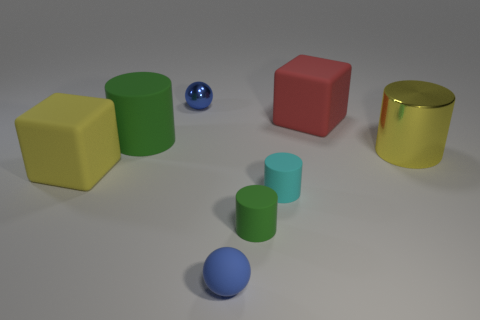Add 2 tiny gray balls. How many objects exist? 10 Subtract all cubes. How many objects are left? 6 Add 3 big yellow rubber objects. How many big yellow rubber objects exist? 4 Subtract 0 green spheres. How many objects are left? 8 Subtract all small purple rubber things. Subtract all tiny cyan things. How many objects are left? 7 Add 3 small rubber cylinders. How many small rubber cylinders are left? 5 